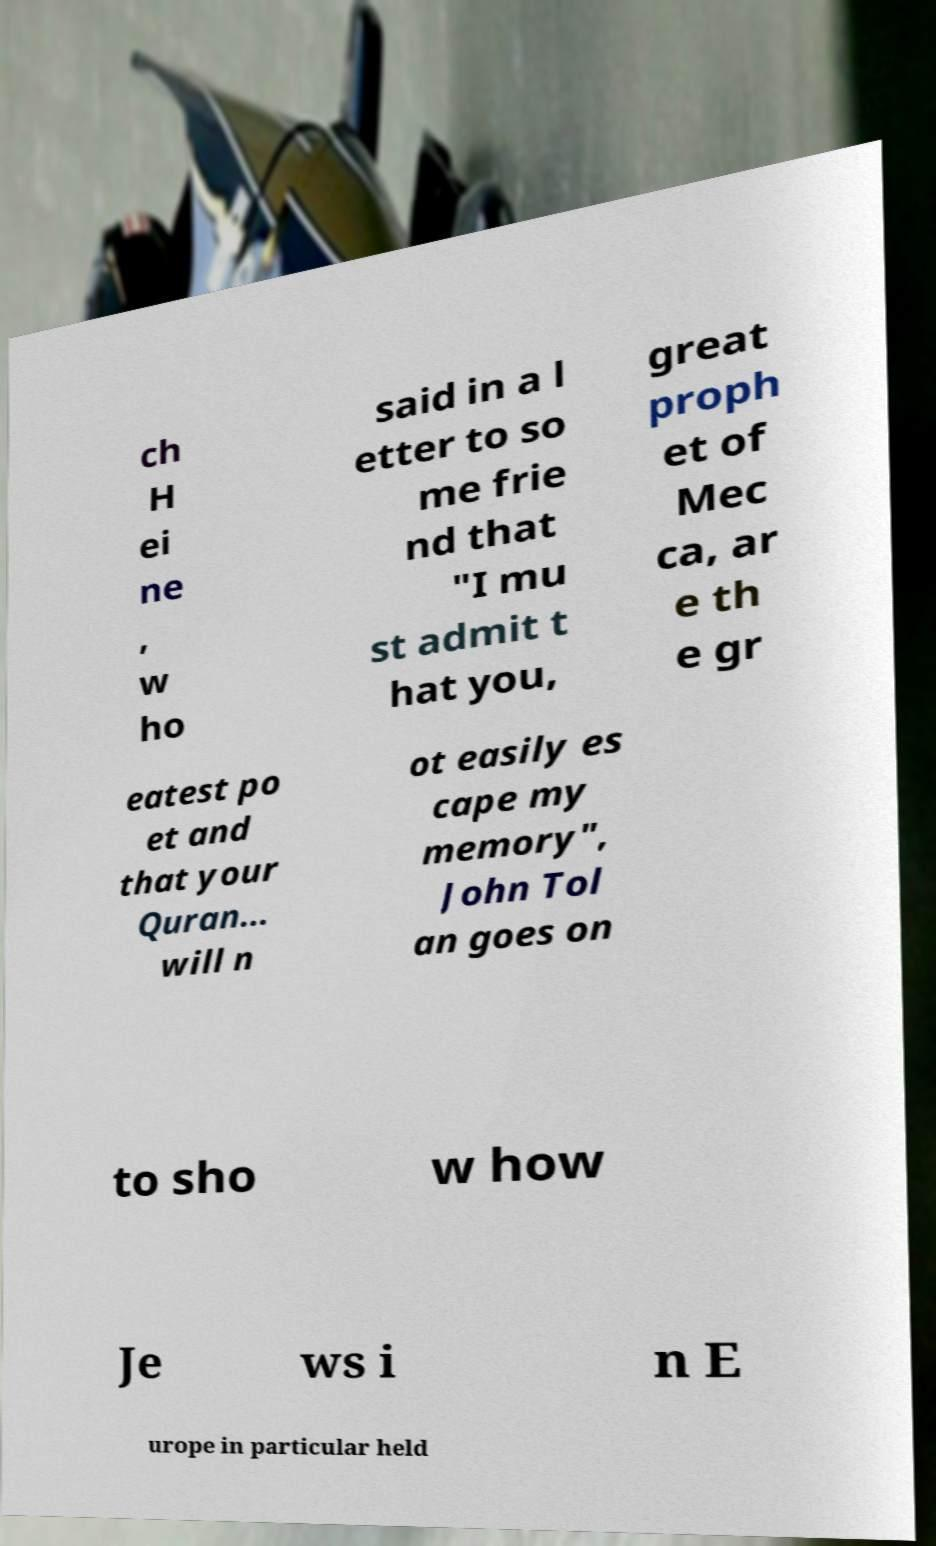Could you extract and type out the text from this image? ch H ei ne , w ho said in a l etter to so me frie nd that "I mu st admit t hat you, great proph et of Mec ca, ar e th e gr eatest po et and that your Quran... will n ot easily es cape my memory", John Tol an goes on to sho w how Je ws i n E urope in particular held 